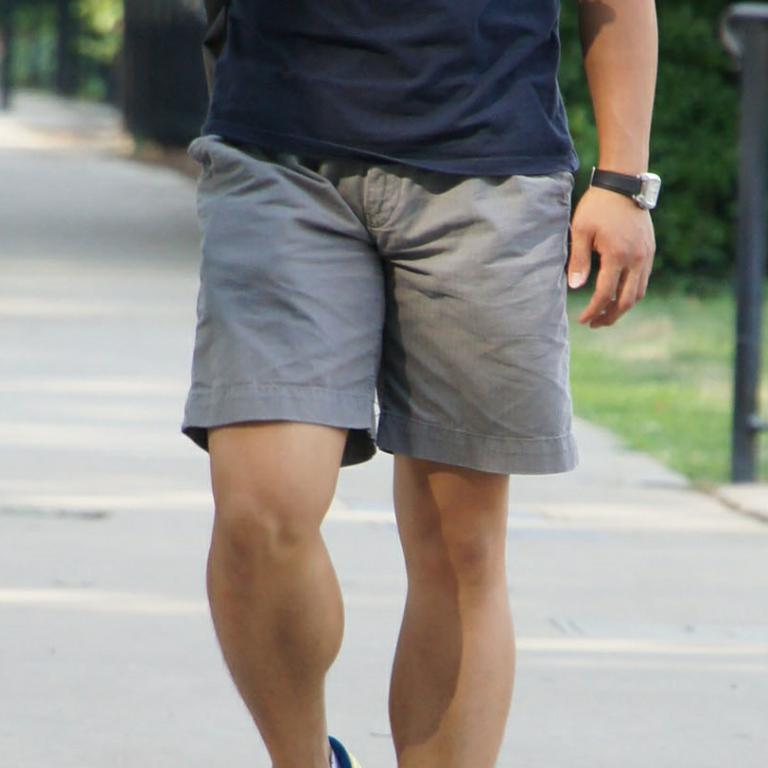What is the main subject of the image? The main subject of the image is a man. How much of the man's body is visible in the picture? Only the half part of the man's body is visible in the picture. How many children are playing with the sink in the image? There is no sink or children present in the image; it features a man with only half of his body visible. 